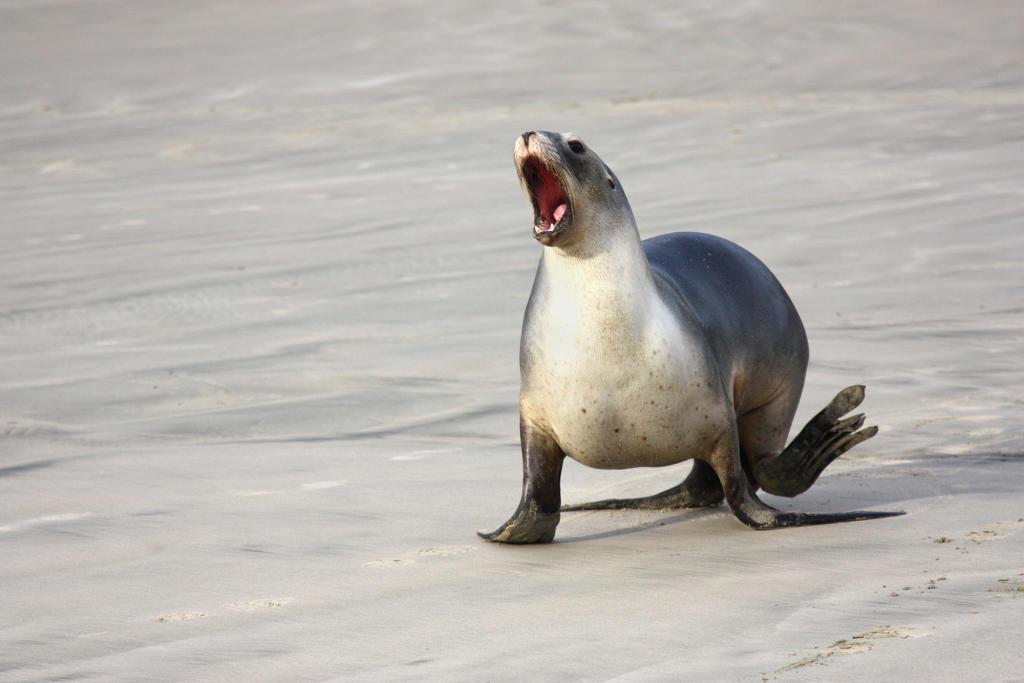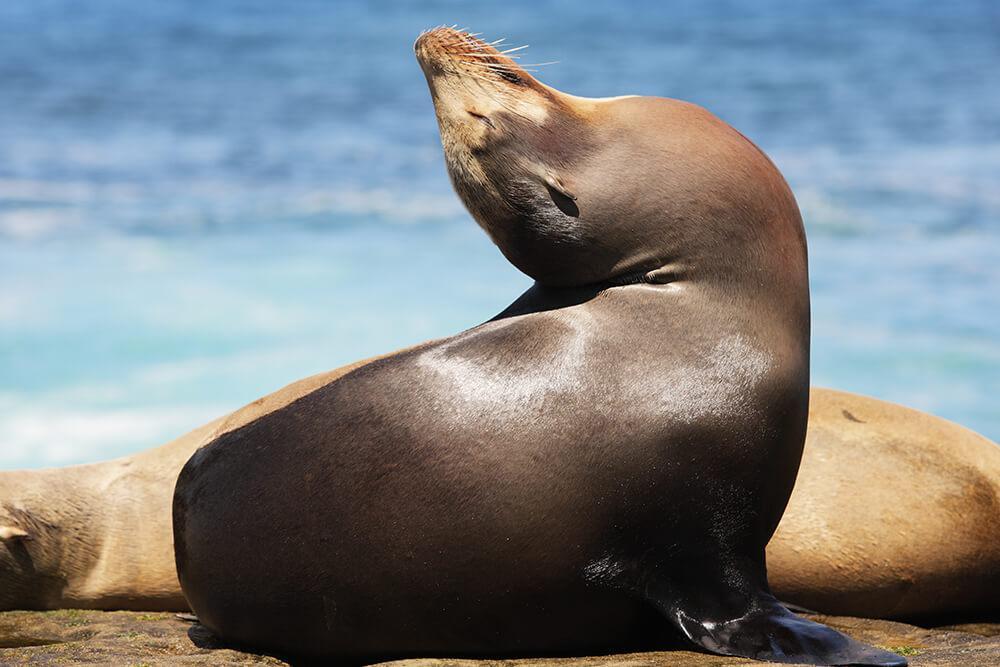The first image is the image on the left, the second image is the image on the right. Evaluate the accuracy of this statement regarding the images: "there is a body of water on the right image". Is it true? Answer yes or no. Yes. 